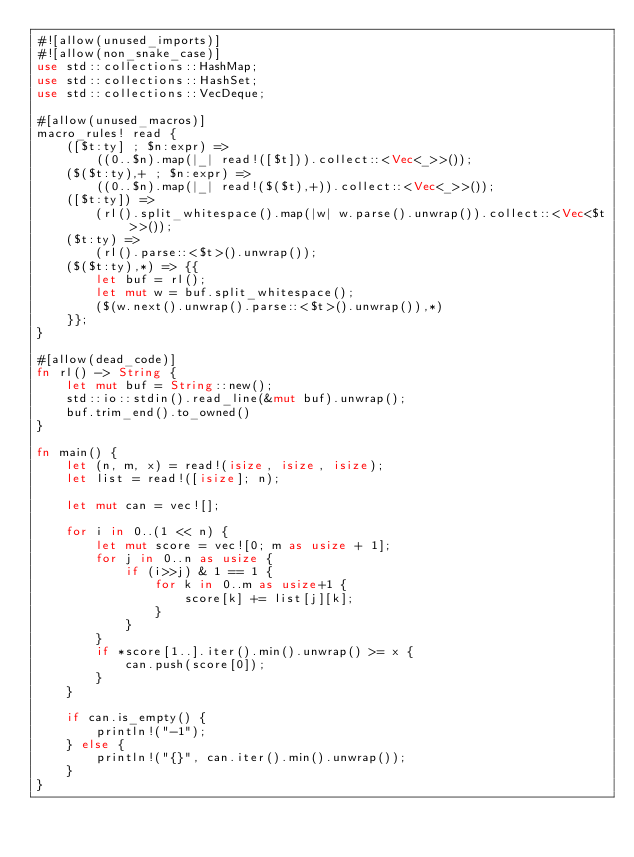Convert code to text. <code><loc_0><loc_0><loc_500><loc_500><_Rust_>#![allow(unused_imports)]
#![allow(non_snake_case)]
use std::collections::HashMap;
use std::collections::HashSet;
use std::collections::VecDeque;

#[allow(unused_macros)]
macro_rules! read {
    ([$t:ty] ; $n:expr) =>
        ((0..$n).map(|_| read!([$t])).collect::<Vec<_>>());
    ($($t:ty),+ ; $n:expr) =>
        ((0..$n).map(|_| read!($($t),+)).collect::<Vec<_>>());
    ([$t:ty]) =>
        (rl().split_whitespace().map(|w| w.parse().unwrap()).collect::<Vec<$t>>());
    ($t:ty) =>
        (rl().parse::<$t>().unwrap());
    ($($t:ty),*) => {{
        let buf = rl();
        let mut w = buf.split_whitespace();
        ($(w.next().unwrap().parse::<$t>().unwrap()),*)
    }};
}

#[allow(dead_code)]
fn rl() -> String {
    let mut buf = String::new();
    std::io::stdin().read_line(&mut buf).unwrap();
    buf.trim_end().to_owned()
}

fn main() {
    let (n, m, x) = read!(isize, isize, isize);
    let list = read!([isize]; n);

    let mut can = vec![];
    
    for i in 0..(1 << n) {
        let mut score = vec![0; m as usize + 1];
        for j in 0..n as usize {
            if (i>>j) & 1 == 1 {
                for k in 0..m as usize+1 {
                    score[k] += list[j][k];
                }
            }
        }
        if *score[1..].iter().min().unwrap() >= x {
            can.push(score[0]);
        }
    }
    
    if can.is_empty() {
        println!("-1");
    } else {
        println!("{}", can.iter().min().unwrap());
    }
}
</code> 